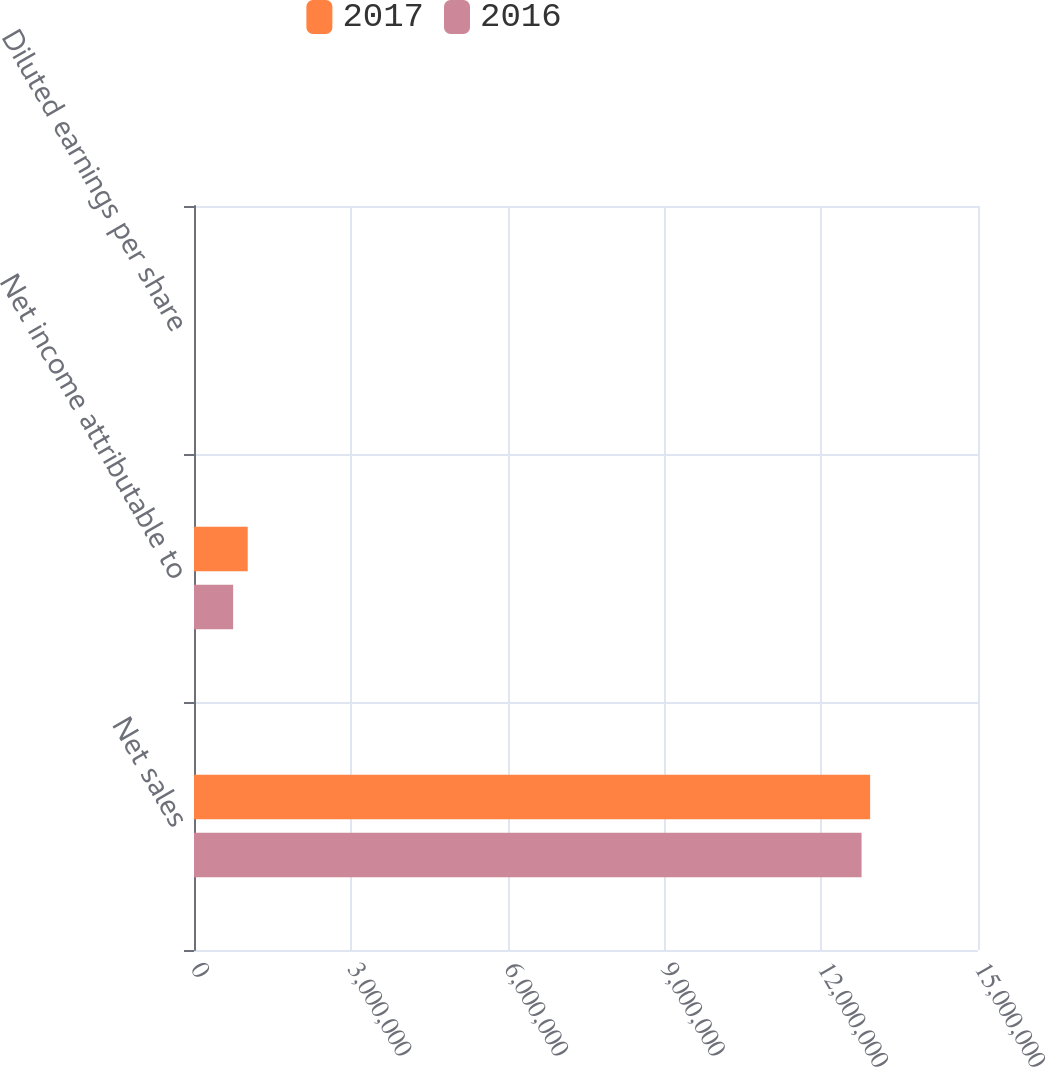Convert chart. <chart><loc_0><loc_0><loc_500><loc_500><stacked_bar_chart><ecel><fcel>Net sales<fcel>Net income attributable to<fcel>Diluted earnings per share<nl><fcel>2017<fcel>1.29358e+07<fcel>1.02769e+06<fcel>7.58<nl><fcel>2016<fcel>1.27721e+07<fcel>748634<fcel>5.47<nl></chart> 